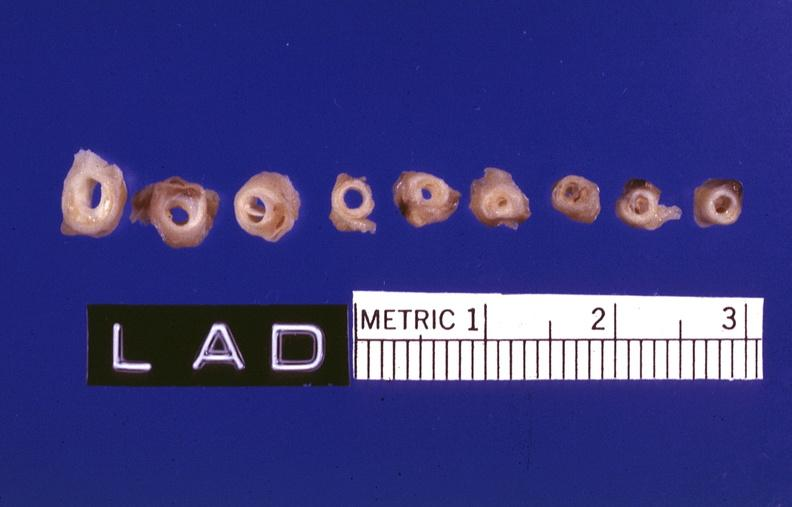what is atherosclerosis left?
Answer the question using a single word or phrase. Anterior descending coronary artery 